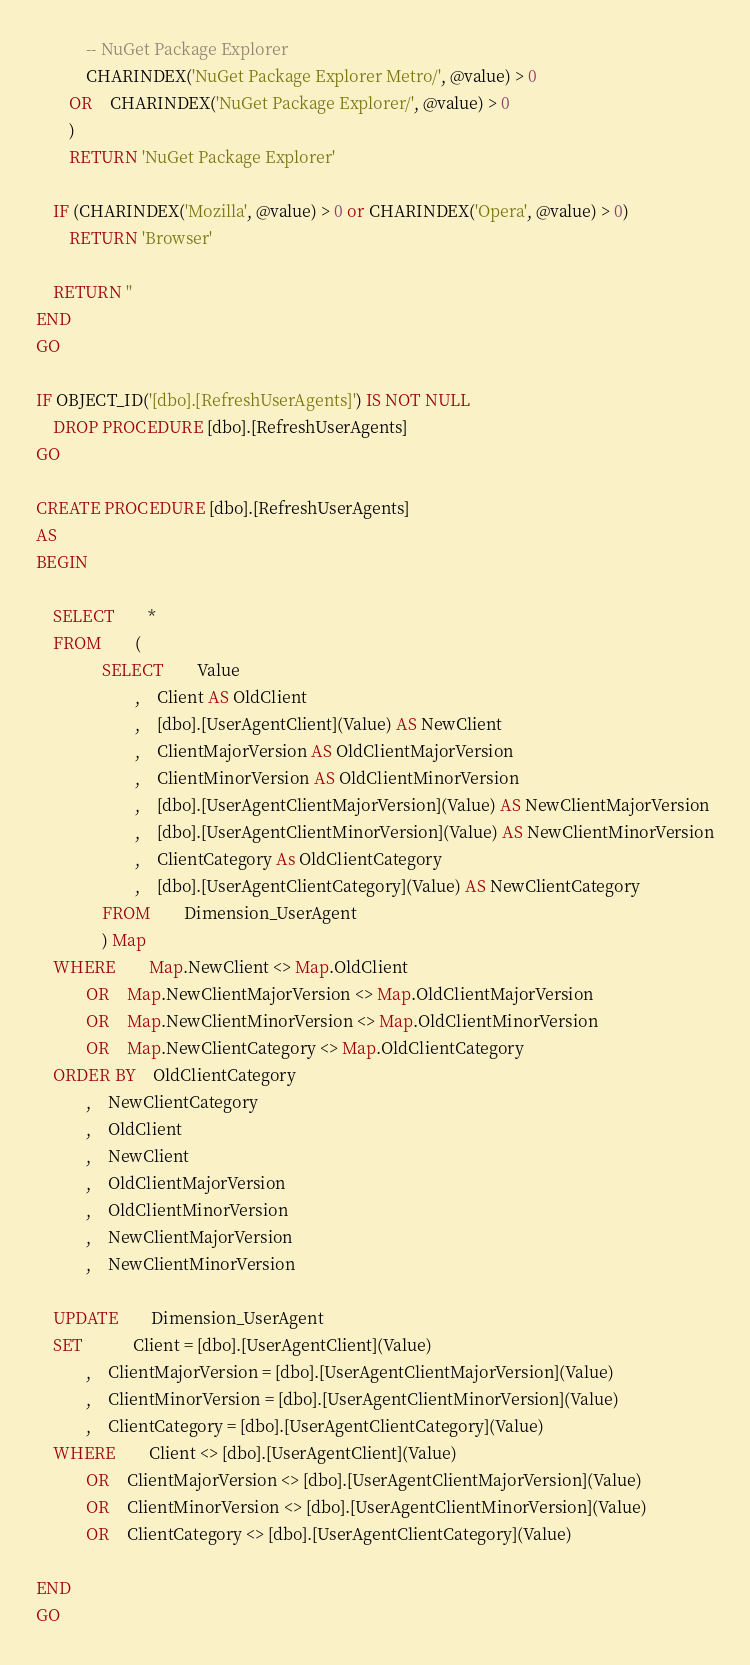Convert code to text. <code><loc_0><loc_0><loc_500><loc_500><_SQL_>			-- NuGet Package Explorer
			CHARINDEX('NuGet Package Explorer Metro/', @value) > 0
		OR	CHARINDEX('NuGet Package Explorer/', @value) > 0
		)
		RETURN 'NuGet Package Explorer'

    IF (CHARINDEX('Mozilla', @value) > 0 or CHARINDEX('Opera', @value) > 0)
        RETURN 'Browser'

    RETURN ''
END
GO

IF OBJECT_ID('[dbo].[RefreshUserAgents]') IS NOT NULL
    DROP PROCEDURE [dbo].[RefreshUserAgents]
GO

CREATE PROCEDURE [dbo].[RefreshUserAgents]
AS
BEGIN

	SELECT		*
	FROM		(
				SELECT		Value
						,	Client AS OldClient
						,	[dbo].[UserAgentClient](Value) AS NewClient
						,	ClientMajorVersion AS OldClientMajorVersion
						,	ClientMinorVersion AS OldClientMinorVersion
						,	[dbo].[UserAgentClientMajorVersion](Value) AS NewClientMajorVersion
						,	[dbo].[UserAgentClientMinorVersion](Value) AS NewClientMinorVersion
						,	ClientCategory As OldClientCategory
						,	[dbo].[UserAgentClientCategory](Value) AS NewClientCategory
				FROM		Dimension_UserAgent
				) Map
	WHERE		Map.NewClient <> Map.OldClient
			OR	Map.NewClientMajorVersion <> Map.OldClientMajorVersion
			OR	Map.NewClientMinorVersion <> Map.OldClientMinorVersion
			OR	Map.NewClientCategory <> Map.OldClientCategory
	ORDER BY	OldClientCategory
			,	NewClientCategory
			,	OldClient
			,	NewClient
			,	OldClientMajorVersion
			,	OldClientMinorVersion
			,	NewClientMajorVersion
			,	NewClientMinorVersion

	UPDATE		Dimension_UserAgent
	SET			Client = [dbo].[UserAgentClient](Value)
			,	ClientMajorVersion = [dbo].[UserAgentClientMajorVersion](Value)
			,	ClientMinorVersion = [dbo].[UserAgentClientMinorVersion](Value)
			,	ClientCategory = [dbo].[UserAgentClientCategory](Value)
	WHERE		Client <> [dbo].[UserAgentClient](Value)
			OR	ClientMajorVersion <> [dbo].[UserAgentClientMajorVersion](Value)
			OR	ClientMinorVersion <> [dbo].[UserAgentClientMinorVersion](Value)
			OR	ClientCategory <> [dbo].[UserAgentClientCategory](Value)

END
GO
</code> 